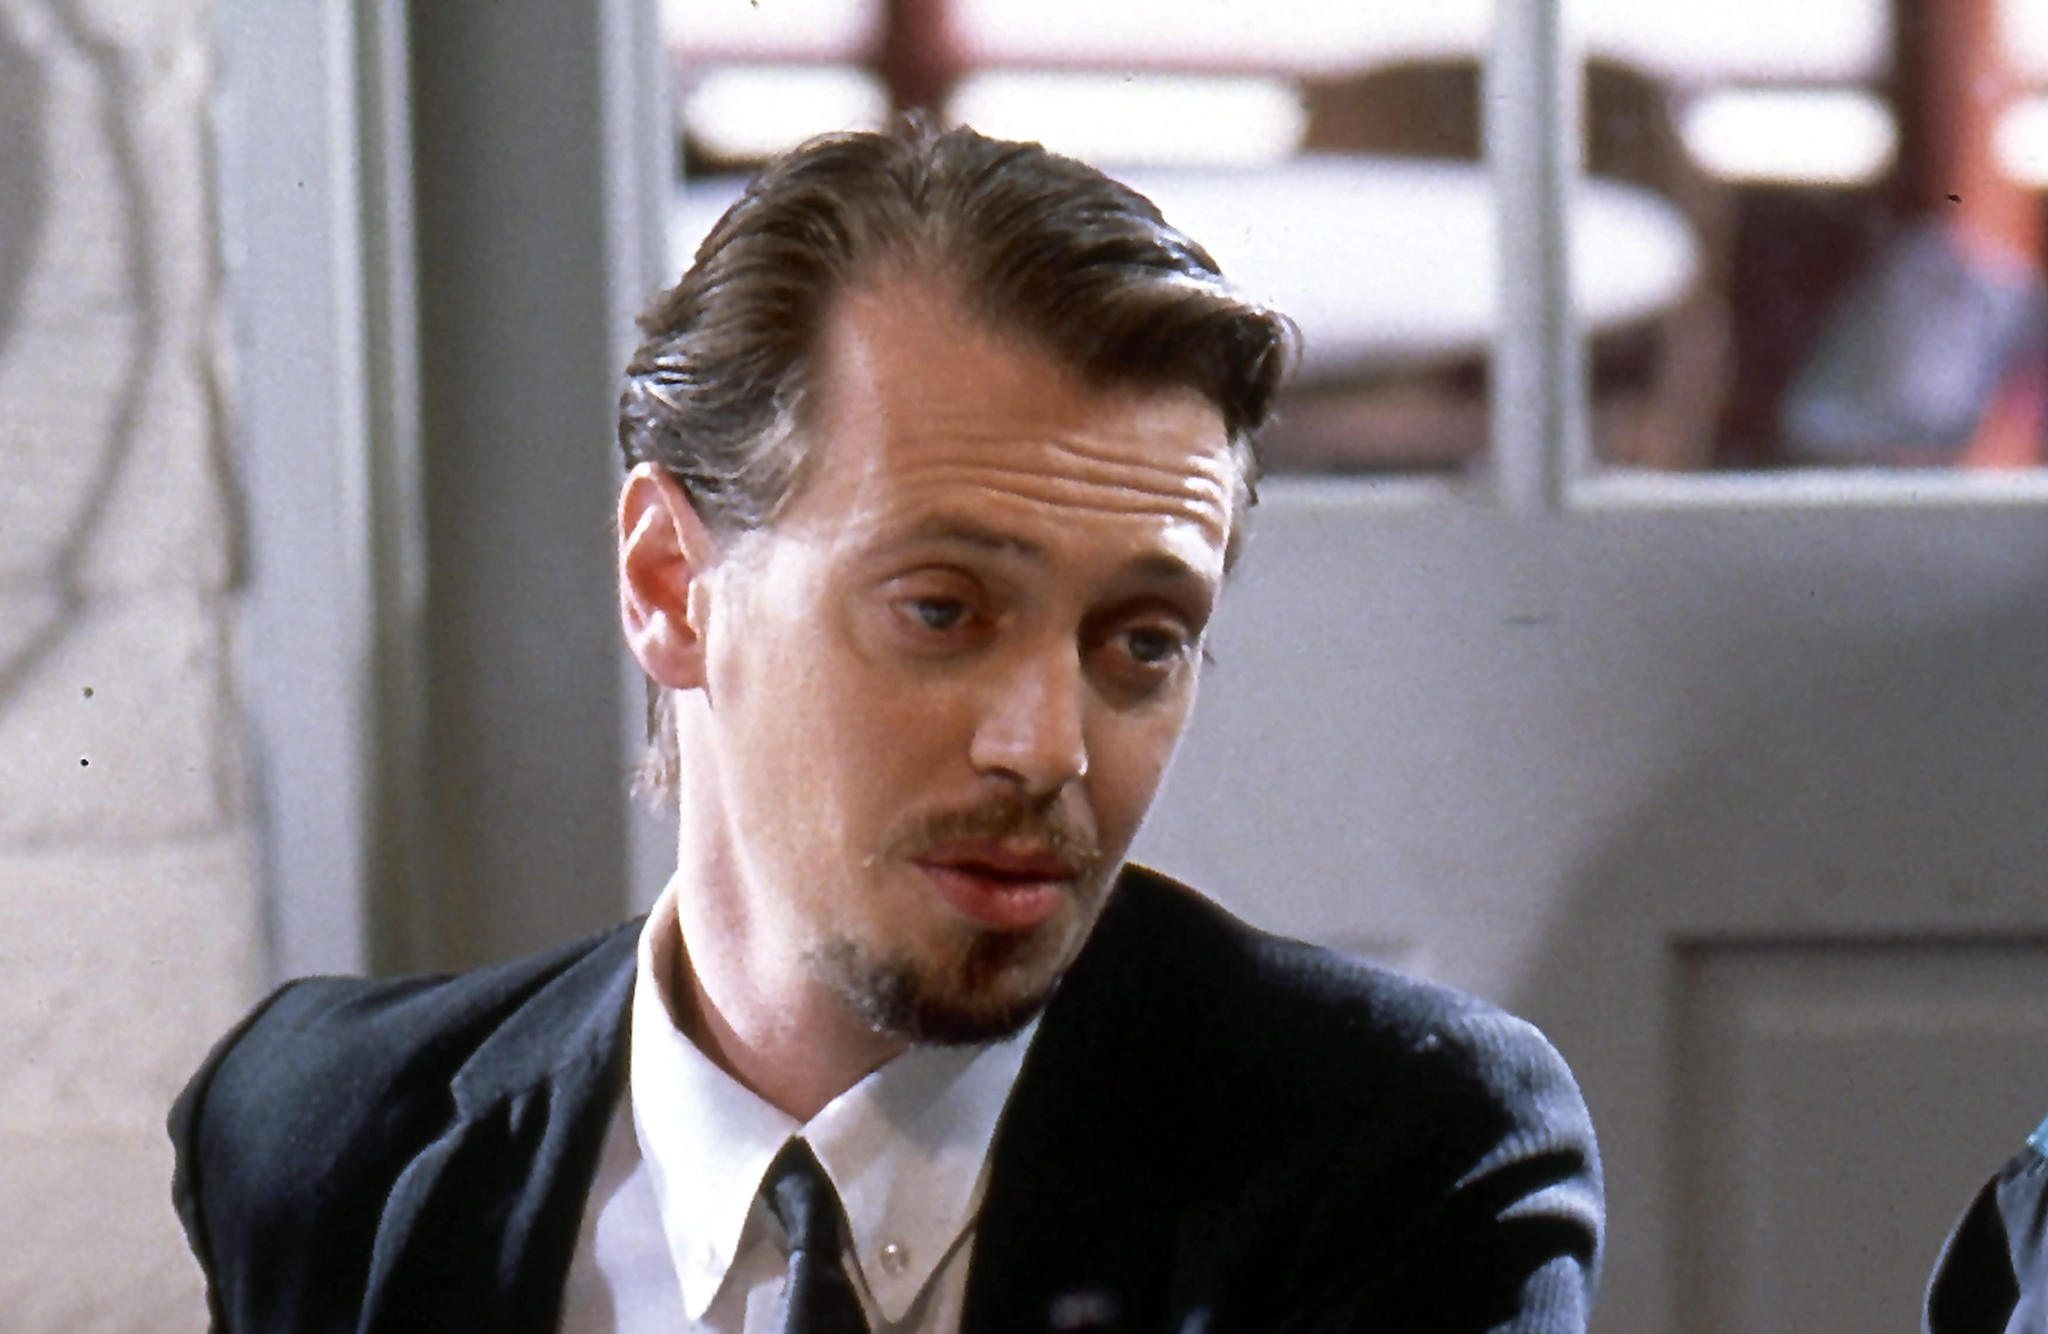What do you see happening in this image? In this image, we see Steve Buscemi portraying his character, Mr. Pink, from the 1992 film 'Reservoir Dogs.' He is seated, seemingly deep in thought, with his gaze directed towards something beyond the image's frame. Mr. Pink is dressed in a formal black suit and tie, creating a striking contrast against his light skin and the somewhat blurred backdrop, which appears to be a cafe or a restaurant. His facial features, including a mustache and goatee, add an additional layer of intensity to his contemplative expression. The scene's lighting and composition emphasize the character's pensive mood, inviting the viewer to ponder what might be going through his mind at this moment. 